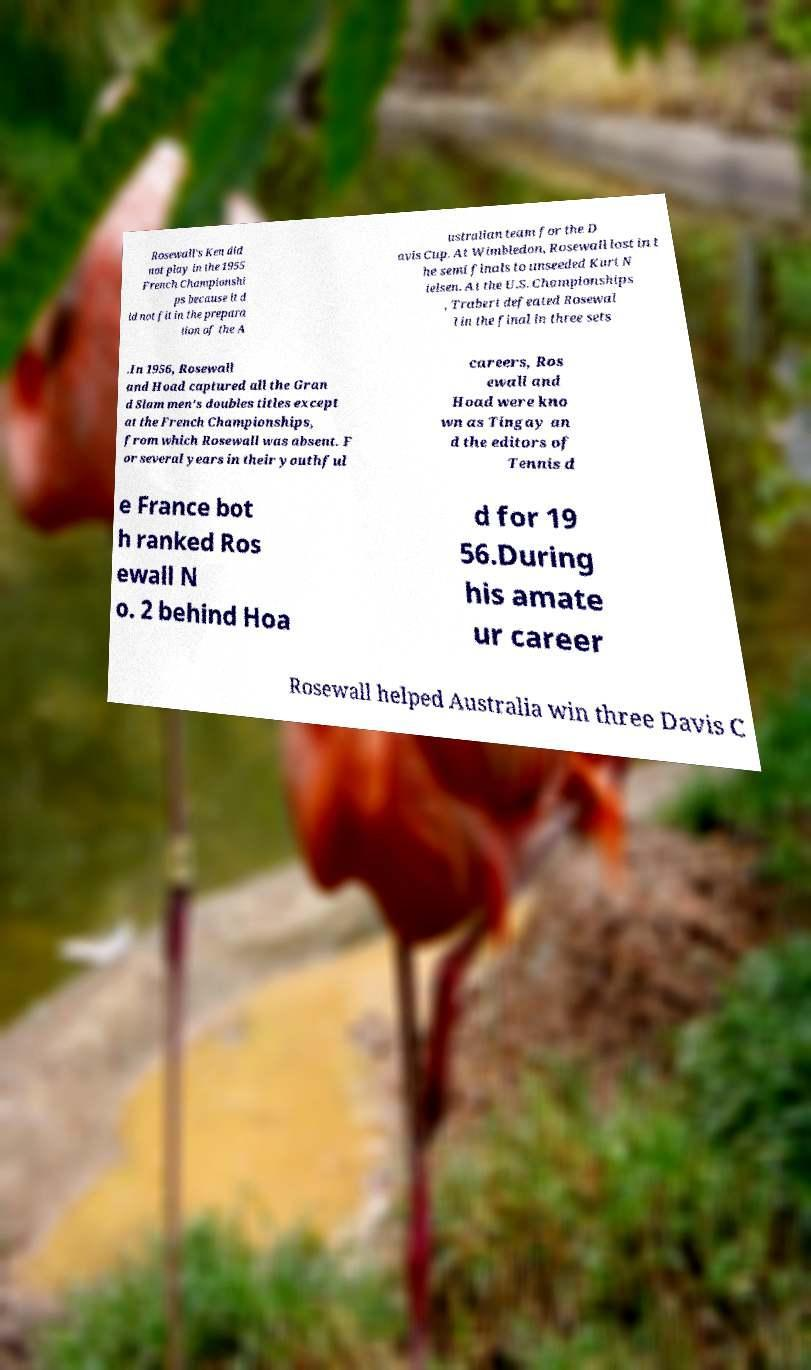For documentation purposes, I need the text within this image transcribed. Could you provide that? Rosewall's Ken did not play in the 1955 French Championshi ps because it d id not fit in the prepara tion of the A ustralian team for the D avis Cup. At Wimbledon, Rosewall lost in t he semi finals to unseeded Kurt N ielsen. At the U.S. Championships , Trabert defeated Rosewal l in the final in three sets .In 1956, Rosewall and Hoad captured all the Gran d Slam men's doubles titles except at the French Championships, from which Rosewall was absent. F or several years in their youthful careers, Ros ewall and Hoad were kno wn as Tingay an d the editors of Tennis d e France bot h ranked Ros ewall N o. 2 behind Hoa d for 19 56.During his amate ur career Rosewall helped Australia win three Davis C 